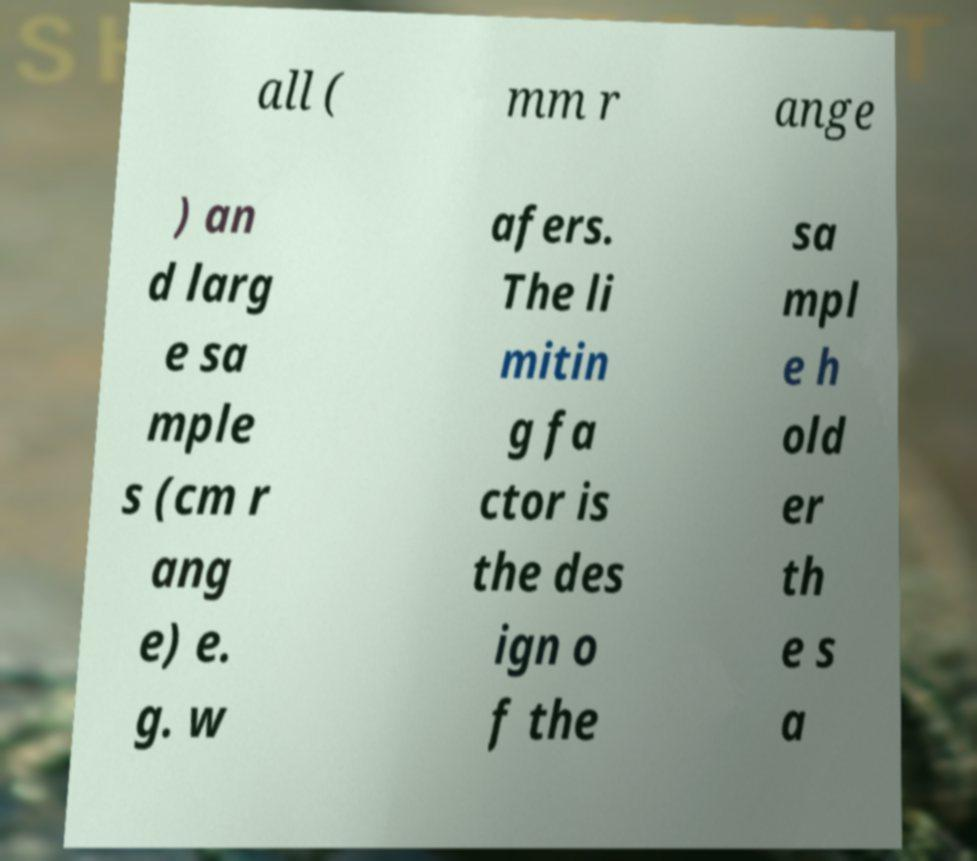I need the written content from this picture converted into text. Can you do that? all ( mm r ange ) an d larg e sa mple s (cm r ang e) e. g. w afers. The li mitin g fa ctor is the des ign o f the sa mpl e h old er th e s a 